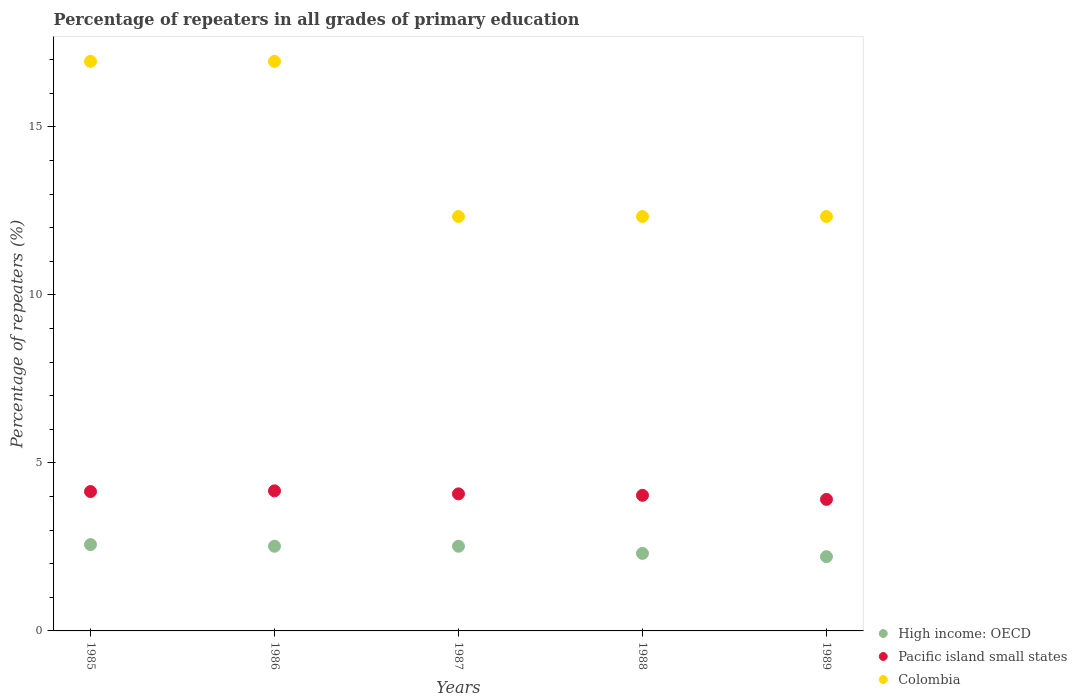Is the number of dotlines equal to the number of legend labels?
Offer a very short reply. Yes. What is the percentage of repeaters in High income: OECD in 1985?
Offer a very short reply. 2.57. Across all years, what is the maximum percentage of repeaters in Colombia?
Your answer should be very brief. 16.95. Across all years, what is the minimum percentage of repeaters in High income: OECD?
Make the answer very short. 2.21. In which year was the percentage of repeaters in High income: OECD maximum?
Offer a terse response. 1985. In which year was the percentage of repeaters in Pacific island small states minimum?
Provide a succinct answer. 1989. What is the total percentage of repeaters in High income: OECD in the graph?
Give a very brief answer. 12.13. What is the difference between the percentage of repeaters in Pacific island small states in 1987 and that in 1988?
Offer a terse response. 0.04. What is the difference between the percentage of repeaters in High income: OECD in 1985 and the percentage of repeaters in Pacific island small states in 1988?
Give a very brief answer. -1.47. What is the average percentage of repeaters in High income: OECD per year?
Give a very brief answer. 2.43. In the year 1985, what is the difference between the percentage of repeaters in High income: OECD and percentage of repeaters in Pacific island small states?
Your answer should be compact. -1.58. Is the difference between the percentage of repeaters in High income: OECD in 1986 and 1988 greater than the difference between the percentage of repeaters in Pacific island small states in 1986 and 1988?
Make the answer very short. Yes. What is the difference between the highest and the lowest percentage of repeaters in High income: OECD?
Keep it short and to the point. 0.36. In how many years, is the percentage of repeaters in Colombia greater than the average percentage of repeaters in Colombia taken over all years?
Give a very brief answer. 2. Does the percentage of repeaters in High income: OECD monotonically increase over the years?
Your response must be concise. No. Is the percentage of repeaters in Pacific island small states strictly greater than the percentage of repeaters in High income: OECD over the years?
Provide a short and direct response. Yes. Is the percentage of repeaters in Pacific island small states strictly less than the percentage of repeaters in High income: OECD over the years?
Offer a terse response. No. How many years are there in the graph?
Offer a terse response. 5. Are the values on the major ticks of Y-axis written in scientific E-notation?
Your response must be concise. No. Does the graph contain any zero values?
Make the answer very short. No. Where does the legend appear in the graph?
Your answer should be very brief. Bottom right. How many legend labels are there?
Give a very brief answer. 3. What is the title of the graph?
Provide a short and direct response. Percentage of repeaters in all grades of primary education. What is the label or title of the Y-axis?
Keep it short and to the point. Percentage of repeaters (%). What is the Percentage of repeaters (%) in High income: OECD in 1985?
Keep it short and to the point. 2.57. What is the Percentage of repeaters (%) in Pacific island small states in 1985?
Provide a short and direct response. 4.15. What is the Percentage of repeaters (%) of Colombia in 1985?
Give a very brief answer. 16.95. What is the Percentage of repeaters (%) in High income: OECD in 1986?
Offer a very short reply. 2.52. What is the Percentage of repeaters (%) in Pacific island small states in 1986?
Offer a very short reply. 4.17. What is the Percentage of repeaters (%) in Colombia in 1986?
Your answer should be compact. 16.95. What is the Percentage of repeaters (%) in High income: OECD in 1987?
Keep it short and to the point. 2.52. What is the Percentage of repeaters (%) in Pacific island small states in 1987?
Give a very brief answer. 4.08. What is the Percentage of repeaters (%) in Colombia in 1987?
Make the answer very short. 12.33. What is the Percentage of repeaters (%) in High income: OECD in 1988?
Offer a very short reply. 2.31. What is the Percentage of repeaters (%) of Pacific island small states in 1988?
Ensure brevity in your answer.  4.04. What is the Percentage of repeaters (%) of Colombia in 1988?
Make the answer very short. 12.33. What is the Percentage of repeaters (%) in High income: OECD in 1989?
Give a very brief answer. 2.21. What is the Percentage of repeaters (%) in Pacific island small states in 1989?
Ensure brevity in your answer.  3.92. What is the Percentage of repeaters (%) of Colombia in 1989?
Your response must be concise. 12.33. Across all years, what is the maximum Percentage of repeaters (%) of High income: OECD?
Ensure brevity in your answer.  2.57. Across all years, what is the maximum Percentage of repeaters (%) of Pacific island small states?
Give a very brief answer. 4.17. Across all years, what is the maximum Percentage of repeaters (%) in Colombia?
Offer a very short reply. 16.95. Across all years, what is the minimum Percentage of repeaters (%) in High income: OECD?
Provide a succinct answer. 2.21. Across all years, what is the minimum Percentage of repeaters (%) in Pacific island small states?
Provide a short and direct response. 3.92. Across all years, what is the minimum Percentage of repeaters (%) in Colombia?
Your answer should be compact. 12.33. What is the total Percentage of repeaters (%) of High income: OECD in the graph?
Make the answer very short. 12.13. What is the total Percentage of repeaters (%) of Pacific island small states in the graph?
Ensure brevity in your answer.  20.35. What is the total Percentage of repeaters (%) of Colombia in the graph?
Offer a terse response. 70.91. What is the difference between the Percentage of repeaters (%) of High income: OECD in 1985 and that in 1986?
Offer a very short reply. 0.05. What is the difference between the Percentage of repeaters (%) of Pacific island small states in 1985 and that in 1986?
Keep it short and to the point. -0.02. What is the difference between the Percentage of repeaters (%) in High income: OECD in 1985 and that in 1987?
Provide a succinct answer. 0.05. What is the difference between the Percentage of repeaters (%) in Pacific island small states in 1985 and that in 1987?
Provide a short and direct response. 0.07. What is the difference between the Percentage of repeaters (%) of Colombia in 1985 and that in 1987?
Give a very brief answer. 4.62. What is the difference between the Percentage of repeaters (%) in High income: OECD in 1985 and that in 1988?
Offer a terse response. 0.26. What is the difference between the Percentage of repeaters (%) in Pacific island small states in 1985 and that in 1988?
Ensure brevity in your answer.  0.11. What is the difference between the Percentage of repeaters (%) of Colombia in 1985 and that in 1988?
Provide a succinct answer. 4.62. What is the difference between the Percentage of repeaters (%) in High income: OECD in 1985 and that in 1989?
Keep it short and to the point. 0.36. What is the difference between the Percentage of repeaters (%) of Pacific island small states in 1985 and that in 1989?
Offer a terse response. 0.23. What is the difference between the Percentage of repeaters (%) of Colombia in 1985 and that in 1989?
Your answer should be compact. 4.62. What is the difference between the Percentage of repeaters (%) of Pacific island small states in 1986 and that in 1987?
Your response must be concise. 0.09. What is the difference between the Percentage of repeaters (%) in Colombia in 1986 and that in 1987?
Ensure brevity in your answer.  4.62. What is the difference between the Percentage of repeaters (%) of High income: OECD in 1986 and that in 1988?
Your answer should be compact. 0.21. What is the difference between the Percentage of repeaters (%) in Pacific island small states in 1986 and that in 1988?
Make the answer very short. 0.13. What is the difference between the Percentage of repeaters (%) of Colombia in 1986 and that in 1988?
Your answer should be very brief. 4.62. What is the difference between the Percentage of repeaters (%) in High income: OECD in 1986 and that in 1989?
Your response must be concise. 0.31. What is the difference between the Percentage of repeaters (%) in Pacific island small states in 1986 and that in 1989?
Your answer should be compact. 0.25. What is the difference between the Percentage of repeaters (%) of Colombia in 1986 and that in 1989?
Ensure brevity in your answer.  4.62. What is the difference between the Percentage of repeaters (%) in High income: OECD in 1987 and that in 1988?
Your answer should be compact. 0.21. What is the difference between the Percentage of repeaters (%) in Pacific island small states in 1987 and that in 1988?
Your response must be concise. 0.04. What is the difference between the Percentage of repeaters (%) in High income: OECD in 1987 and that in 1989?
Give a very brief answer. 0.31. What is the difference between the Percentage of repeaters (%) in Pacific island small states in 1987 and that in 1989?
Your response must be concise. 0.16. What is the difference between the Percentage of repeaters (%) of High income: OECD in 1988 and that in 1989?
Keep it short and to the point. 0.1. What is the difference between the Percentage of repeaters (%) in Pacific island small states in 1988 and that in 1989?
Your response must be concise. 0.12. What is the difference between the Percentage of repeaters (%) in High income: OECD in 1985 and the Percentage of repeaters (%) in Pacific island small states in 1986?
Offer a terse response. -1.6. What is the difference between the Percentage of repeaters (%) of High income: OECD in 1985 and the Percentage of repeaters (%) of Colombia in 1986?
Offer a terse response. -14.38. What is the difference between the Percentage of repeaters (%) of Pacific island small states in 1985 and the Percentage of repeaters (%) of Colombia in 1986?
Provide a short and direct response. -12.81. What is the difference between the Percentage of repeaters (%) in High income: OECD in 1985 and the Percentage of repeaters (%) in Pacific island small states in 1987?
Your answer should be very brief. -1.51. What is the difference between the Percentage of repeaters (%) of High income: OECD in 1985 and the Percentage of repeaters (%) of Colombia in 1987?
Give a very brief answer. -9.77. What is the difference between the Percentage of repeaters (%) of Pacific island small states in 1985 and the Percentage of repeaters (%) of Colombia in 1987?
Make the answer very short. -8.19. What is the difference between the Percentage of repeaters (%) in High income: OECD in 1985 and the Percentage of repeaters (%) in Pacific island small states in 1988?
Offer a very short reply. -1.47. What is the difference between the Percentage of repeaters (%) of High income: OECD in 1985 and the Percentage of repeaters (%) of Colombia in 1988?
Keep it short and to the point. -9.77. What is the difference between the Percentage of repeaters (%) of Pacific island small states in 1985 and the Percentage of repeaters (%) of Colombia in 1988?
Ensure brevity in your answer.  -8.19. What is the difference between the Percentage of repeaters (%) in High income: OECD in 1985 and the Percentage of repeaters (%) in Pacific island small states in 1989?
Provide a short and direct response. -1.35. What is the difference between the Percentage of repeaters (%) of High income: OECD in 1985 and the Percentage of repeaters (%) of Colombia in 1989?
Provide a succinct answer. -9.77. What is the difference between the Percentage of repeaters (%) of Pacific island small states in 1985 and the Percentage of repeaters (%) of Colombia in 1989?
Keep it short and to the point. -8.19. What is the difference between the Percentage of repeaters (%) of High income: OECD in 1986 and the Percentage of repeaters (%) of Pacific island small states in 1987?
Ensure brevity in your answer.  -1.56. What is the difference between the Percentage of repeaters (%) in High income: OECD in 1986 and the Percentage of repeaters (%) in Colombia in 1987?
Your response must be concise. -9.81. What is the difference between the Percentage of repeaters (%) in Pacific island small states in 1986 and the Percentage of repeaters (%) in Colombia in 1987?
Provide a short and direct response. -8.17. What is the difference between the Percentage of repeaters (%) of High income: OECD in 1986 and the Percentage of repeaters (%) of Pacific island small states in 1988?
Make the answer very short. -1.52. What is the difference between the Percentage of repeaters (%) of High income: OECD in 1986 and the Percentage of repeaters (%) of Colombia in 1988?
Provide a short and direct response. -9.81. What is the difference between the Percentage of repeaters (%) in Pacific island small states in 1986 and the Percentage of repeaters (%) in Colombia in 1988?
Offer a terse response. -8.17. What is the difference between the Percentage of repeaters (%) of High income: OECD in 1986 and the Percentage of repeaters (%) of Pacific island small states in 1989?
Your response must be concise. -1.39. What is the difference between the Percentage of repeaters (%) in High income: OECD in 1986 and the Percentage of repeaters (%) in Colombia in 1989?
Offer a terse response. -9.81. What is the difference between the Percentage of repeaters (%) of Pacific island small states in 1986 and the Percentage of repeaters (%) of Colombia in 1989?
Provide a short and direct response. -8.17. What is the difference between the Percentage of repeaters (%) of High income: OECD in 1987 and the Percentage of repeaters (%) of Pacific island small states in 1988?
Give a very brief answer. -1.52. What is the difference between the Percentage of repeaters (%) in High income: OECD in 1987 and the Percentage of repeaters (%) in Colombia in 1988?
Offer a terse response. -9.81. What is the difference between the Percentage of repeaters (%) in Pacific island small states in 1987 and the Percentage of repeaters (%) in Colombia in 1988?
Ensure brevity in your answer.  -8.26. What is the difference between the Percentage of repeaters (%) in High income: OECD in 1987 and the Percentage of repeaters (%) in Pacific island small states in 1989?
Offer a terse response. -1.39. What is the difference between the Percentage of repeaters (%) in High income: OECD in 1987 and the Percentage of repeaters (%) in Colombia in 1989?
Offer a very short reply. -9.81. What is the difference between the Percentage of repeaters (%) in Pacific island small states in 1987 and the Percentage of repeaters (%) in Colombia in 1989?
Your response must be concise. -8.26. What is the difference between the Percentage of repeaters (%) of High income: OECD in 1988 and the Percentage of repeaters (%) of Pacific island small states in 1989?
Your answer should be very brief. -1.61. What is the difference between the Percentage of repeaters (%) of High income: OECD in 1988 and the Percentage of repeaters (%) of Colombia in 1989?
Offer a very short reply. -10.03. What is the difference between the Percentage of repeaters (%) of Pacific island small states in 1988 and the Percentage of repeaters (%) of Colombia in 1989?
Your answer should be very brief. -8.3. What is the average Percentage of repeaters (%) in High income: OECD per year?
Ensure brevity in your answer.  2.43. What is the average Percentage of repeaters (%) in Pacific island small states per year?
Make the answer very short. 4.07. What is the average Percentage of repeaters (%) of Colombia per year?
Give a very brief answer. 14.18. In the year 1985, what is the difference between the Percentage of repeaters (%) of High income: OECD and Percentage of repeaters (%) of Pacific island small states?
Make the answer very short. -1.58. In the year 1985, what is the difference between the Percentage of repeaters (%) of High income: OECD and Percentage of repeaters (%) of Colombia?
Offer a very short reply. -14.38. In the year 1985, what is the difference between the Percentage of repeaters (%) in Pacific island small states and Percentage of repeaters (%) in Colombia?
Your answer should be compact. -12.81. In the year 1986, what is the difference between the Percentage of repeaters (%) of High income: OECD and Percentage of repeaters (%) of Pacific island small states?
Offer a terse response. -1.65. In the year 1986, what is the difference between the Percentage of repeaters (%) of High income: OECD and Percentage of repeaters (%) of Colombia?
Offer a very short reply. -14.43. In the year 1986, what is the difference between the Percentage of repeaters (%) of Pacific island small states and Percentage of repeaters (%) of Colombia?
Make the answer very short. -12.78. In the year 1987, what is the difference between the Percentage of repeaters (%) of High income: OECD and Percentage of repeaters (%) of Pacific island small states?
Provide a succinct answer. -1.56. In the year 1987, what is the difference between the Percentage of repeaters (%) in High income: OECD and Percentage of repeaters (%) in Colombia?
Provide a short and direct response. -9.81. In the year 1987, what is the difference between the Percentage of repeaters (%) in Pacific island small states and Percentage of repeaters (%) in Colombia?
Make the answer very short. -8.26. In the year 1988, what is the difference between the Percentage of repeaters (%) in High income: OECD and Percentage of repeaters (%) in Pacific island small states?
Your answer should be very brief. -1.73. In the year 1988, what is the difference between the Percentage of repeaters (%) of High income: OECD and Percentage of repeaters (%) of Colombia?
Keep it short and to the point. -10.03. In the year 1988, what is the difference between the Percentage of repeaters (%) of Pacific island small states and Percentage of repeaters (%) of Colombia?
Your response must be concise. -8.3. In the year 1989, what is the difference between the Percentage of repeaters (%) in High income: OECD and Percentage of repeaters (%) in Pacific island small states?
Ensure brevity in your answer.  -1.71. In the year 1989, what is the difference between the Percentage of repeaters (%) of High income: OECD and Percentage of repeaters (%) of Colombia?
Keep it short and to the point. -10.12. In the year 1989, what is the difference between the Percentage of repeaters (%) in Pacific island small states and Percentage of repeaters (%) in Colombia?
Make the answer very short. -8.42. What is the ratio of the Percentage of repeaters (%) in High income: OECD in 1985 to that in 1986?
Provide a short and direct response. 1.02. What is the ratio of the Percentage of repeaters (%) in Colombia in 1985 to that in 1986?
Your answer should be compact. 1. What is the ratio of the Percentage of repeaters (%) in High income: OECD in 1985 to that in 1987?
Your answer should be compact. 1.02. What is the ratio of the Percentage of repeaters (%) in Pacific island small states in 1985 to that in 1987?
Ensure brevity in your answer.  1.02. What is the ratio of the Percentage of repeaters (%) in Colombia in 1985 to that in 1987?
Give a very brief answer. 1.37. What is the ratio of the Percentage of repeaters (%) in High income: OECD in 1985 to that in 1988?
Offer a terse response. 1.11. What is the ratio of the Percentage of repeaters (%) in Pacific island small states in 1985 to that in 1988?
Give a very brief answer. 1.03. What is the ratio of the Percentage of repeaters (%) in Colombia in 1985 to that in 1988?
Provide a succinct answer. 1.37. What is the ratio of the Percentage of repeaters (%) of High income: OECD in 1985 to that in 1989?
Provide a succinct answer. 1.16. What is the ratio of the Percentage of repeaters (%) in Pacific island small states in 1985 to that in 1989?
Give a very brief answer. 1.06. What is the ratio of the Percentage of repeaters (%) of Colombia in 1985 to that in 1989?
Your answer should be very brief. 1.37. What is the ratio of the Percentage of repeaters (%) in Pacific island small states in 1986 to that in 1987?
Offer a terse response. 1.02. What is the ratio of the Percentage of repeaters (%) of Colombia in 1986 to that in 1987?
Make the answer very short. 1.37. What is the ratio of the Percentage of repeaters (%) in High income: OECD in 1986 to that in 1988?
Provide a short and direct response. 1.09. What is the ratio of the Percentage of repeaters (%) of Pacific island small states in 1986 to that in 1988?
Ensure brevity in your answer.  1.03. What is the ratio of the Percentage of repeaters (%) in Colombia in 1986 to that in 1988?
Provide a succinct answer. 1.37. What is the ratio of the Percentage of repeaters (%) of High income: OECD in 1986 to that in 1989?
Give a very brief answer. 1.14. What is the ratio of the Percentage of repeaters (%) in Pacific island small states in 1986 to that in 1989?
Provide a succinct answer. 1.06. What is the ratio of the Percentage of repeaters (%) in Colombia in 1986 to that in 1989?
Provide a succinct answer. 1.37. What is the ratio of the Percentage of repeaters (%) in High income: OECD in 1987 to that in 1988?
Your response must be concise. 1.09. What is the ratio of the Percentage of repeaters (%) of Pacific island small states in 1987 to that in 1988?
Your answer should be compact. 1.01. What is the ratio of the Percentage of repeaters (%) of Colombia in 1987 to that in 1988?
Keep it short and to the point. 1. What is the ratio of the Percentage of repeaters (%) of High income: OECD in 1987 to that in 1989?
Give a very brief answer. 1.14. What is the ratio of the Percentage of repeaters (%) in Pacific island small states in 1987 to that in 1989?
Ensure brevity in your answer.  1.04. What is the ratio of the Percentage of repeaters (%) of Colombia in 1987 to that in 1989?
Offer a very short reply. 1. What is the ratio of the Percentage of repeaters (%) in High income: OECD in 1988 to that in 1989?
Keep it short and to the point. 1.04. What is the ratio of the Percentage of repeaters (%) in Pacific island small states in 1988 to that in 1989?
Your response must be concise. 1.03. What is the ratio of the Percentage of repeaters (%) of Colombia in 1988 to that in 1989?
Offer a terse response. 1. What is the difference between the highest and the second highest Percentage of repeaters (%) in High income: OECD?
Offer a very short reply. 0.05. What is the difference between the highest and the second highest Percentage of repeaters (%) of Pacific island small states?
Your answer should be compact. 0.02. What is the difference between the highest and the lowest Percentage of repeaters (%) in High income: OECD?
Make the answer very short. 0.36. What is the difference between the highest and the lowest Percentage of repeaters (%) in Pacific island small states?
Your response must be concise. 0.25. What is the difference between the highest and the lowest Percentage of repeaters (%) of Colombia?
Your answer should be very brief. 4.62. 